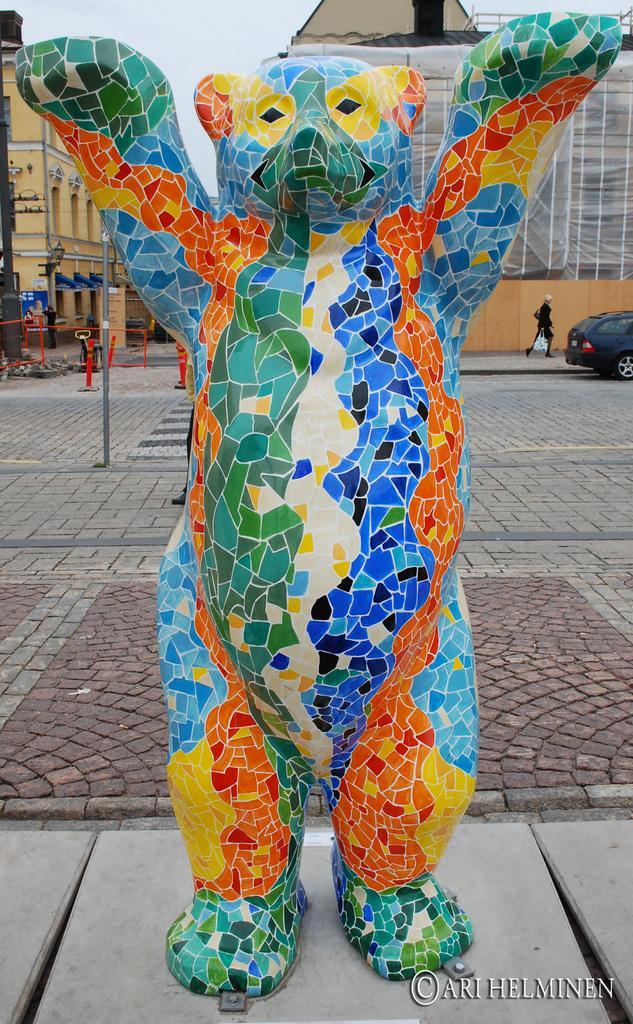Please provide a concise description of this image. In this image we can see a statue on the ground. On the backside we can see a car, a person standing holding a cover, some poles, buildings and the sky which looks cloudy. On the bottom of the image we can see some text. 